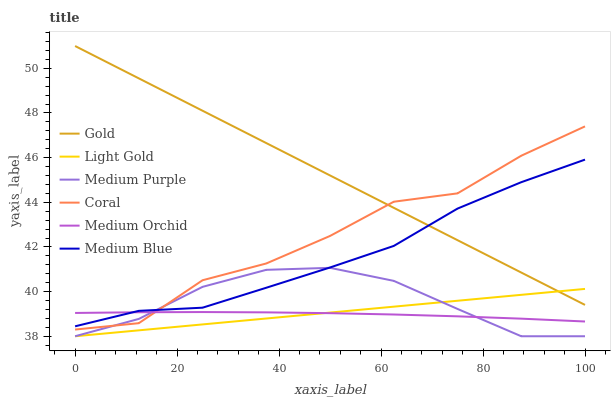Does Medium Orchid have the minimum area under the curve?
Answer yes or no. Yes. Does Gold have the maximum area under the curve?
Answer yes or no. Yes. Does Coral have the minimum area under the curve?
Answer yes or no. No. Does Coral have the maximum area under the curve?
Answer yes or no. No. Is Gold the smoothest?
Answer yes or no. Yes. Is Coral the roughest?
Answer yes or no. Yes. Is Medium Orchid the smoothest?
Answer yes or no. No. Is Medium Orchid the roughest?
Answer yes or no. No. Does Medium Purple have the lowest value?
Answer yes or no. Yes. Does Coral have the lowest value?
Answer yes or no. No. Does Gold have the highest value?
Answer yes or no. Yes. Does Coral have the highest value?
Answer yes or no. No. Is Medium Purple less than Gold?
Answer yes or no. Yes. Is Gold greater than Medium Orchid?
Answer yes or no. Yes. Does Medium Orchid intersect Medium Blue?
Answer yes or no. Yes. Is Medium Orchid less than Medium Blue?
Answer yes or no. No. Is Medium Orchid greater than Medium Blue?
Answer yes or no. No. Does Medium Purple intersect Gold?
Answer yes or no. No. 